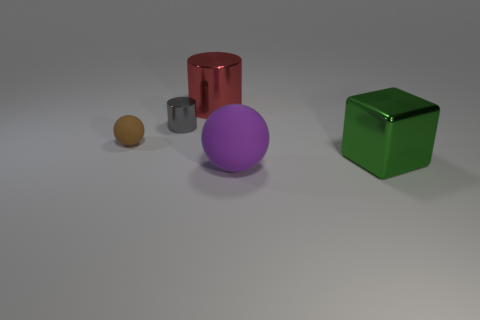How many other objects are there of the same size as the gray cylinder?
Make the answer very short. 1. What number of tiny brown matte objects are the same shape as the large purple object?
Offer a very short reply. 1. There is a object that is behind the tiny sphere and left of the red thing; what is its material?
Your response must be concise. Metal. There is a purple thing; how many small matte spheres are in front of it?
Offer a terse response. 0. How many brown spheres are there?
Your answer should be compact. 1. Is the size of the gray metal cylinder the same as the brown rubber thing?
Provide a short and direct response. Yes. Is there a big object in front of the big shiny thing to the right of the large shiny thing that is behind the small gray metallic cylinder?
Your answer should be compact. Yes. There is a purple thing that is the same shape as the brown thing; what is its material?
Give a very brief answer. Rubber. There is a sphere that is behind the big ball; what is its color?
Offer a very short reply. Brown. What is the size of the brown rubber thing?
Keep it short and to the point. Small. 